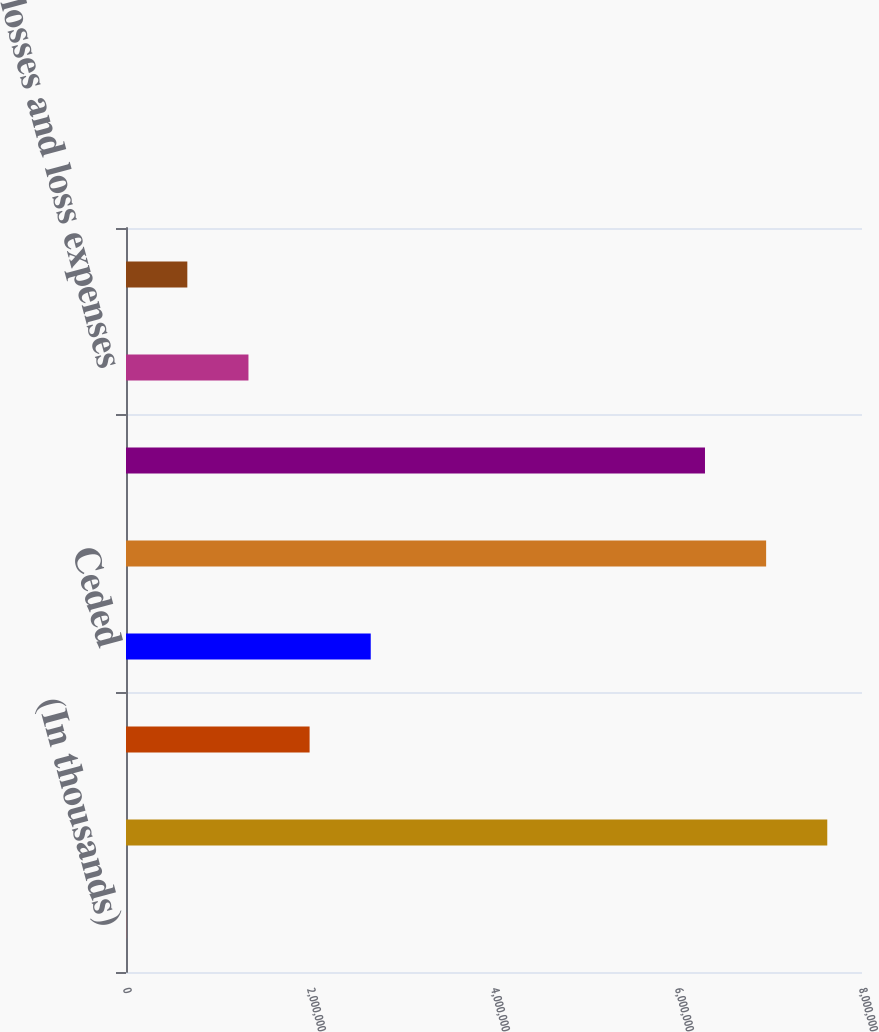Convert chart to OTSL. <chart><loc_0><loc_0><loc_500><loc_500><bar_chart><fcel>(In thousands)<fcel>Direct<fcel>Assumed<fcel>Ceded<fcel>Total net written premiums<fcel>Total net earned premiums<fcel>Ceded losses and loss expenses<fcel>Ceded commission earned<nl><fcel>2016<fcel>7.62246e+06<fcel>1.99569e+06<fcel>2.66025e+06<fcel>6.95791e+06<fcel>6.29335e+06<fcel>1.33113e+06<fcel>666574<nl></chart> 